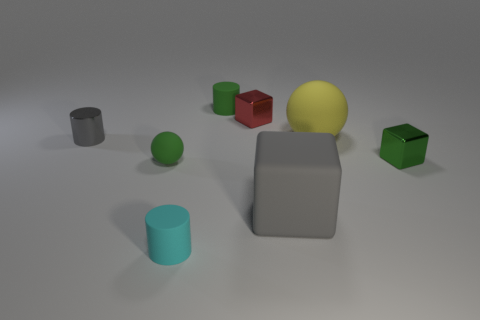There is a yellow object that is the same size as the gray block; what is its shape? The yellow object that matches the gray block in size is spherical in shape, displaying a smooth, even surface characteristic of spheres. 